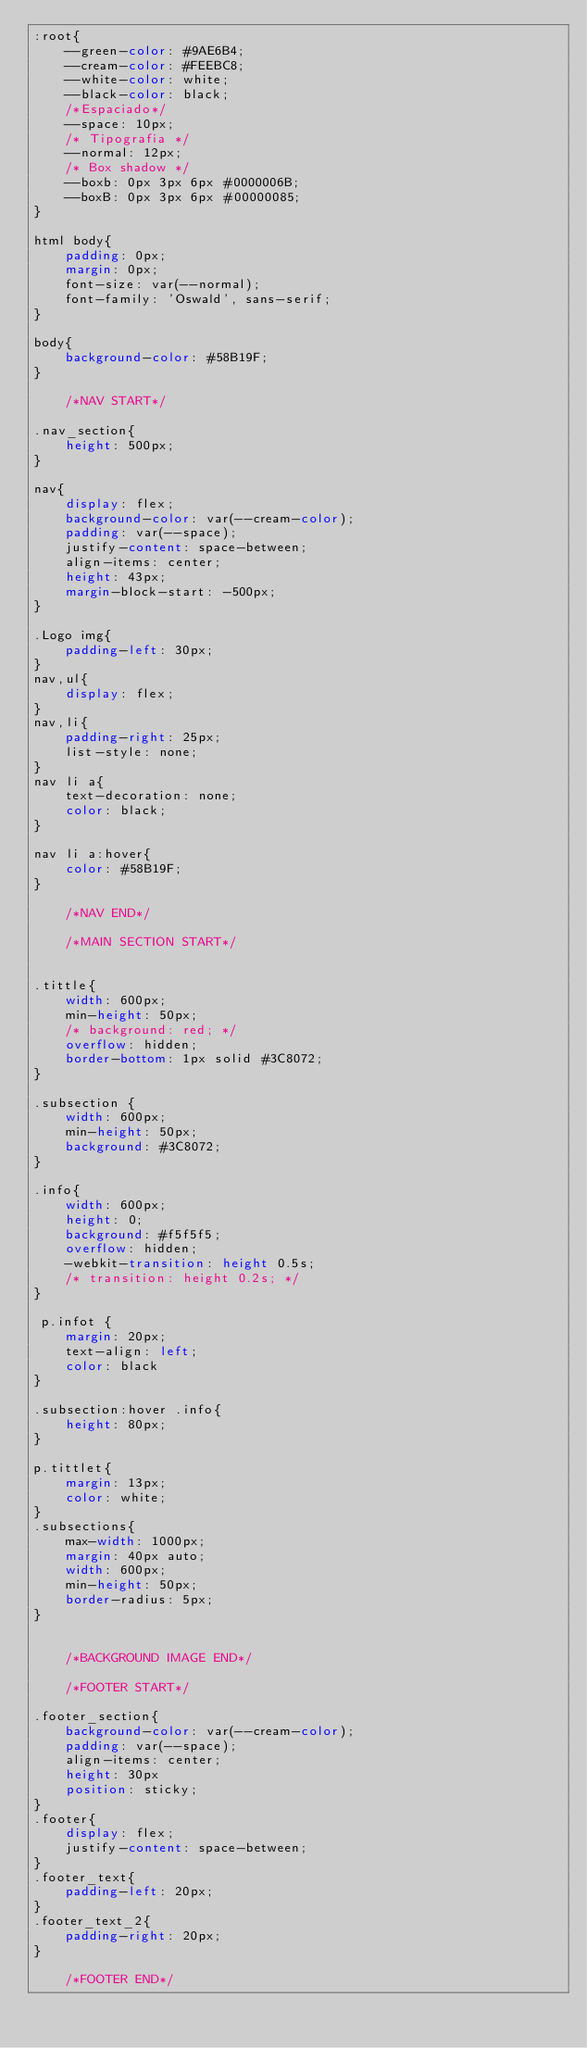<code> <loc_0><loc_0><loc_500><loc_500><_CSS_>:root{
	--green-color: #9AE6B4;
	--cream-color: #FEEBC8;
	--white-color: white;
	--black-color: black;
	/*Espaciado*/
	--space: 10px;
	/* Tipografia */
	--normal: 12px;
	/* Box shadow */
	--boxb: 0px 3px 6px #0000006B;
	--boxB: 0px 3px 6px #00000085;
}

html body{
	padding: 0px; 
	margin: 0px;
	font-size: var(--normal);
	font-family: 'Oswald', sans-serif;
}

body{
	background-color: #58B19F;
}

	/*NAV START*/

.nav_section{
	height: 500px;
}

nav{
	display: flex;
	background-color: var(--cream-color);
	padding: var(--space);
	justify-content: space-between;
	align-items: center;
	height: 43px;
	margin-block-start: -500px;
}

.Logo img{
	padding-left: 30px;
}
nav,ul{
	display: flex;
}
nav,li{
	padding-right: 25px; 
	list-style: none;
}
nav li a{
	text-decoration: none;
	color: black;
}

nav li a:hover{
	color: #58B19F;
}

	/*NAV END*/

	/*MAIN SECTION START*/


.tittle{
    width: 600px;
    min-height: 50px;
    /* background: red; */
    overflow: hidden;
    border-bottom: 1px solid #3C8072;
}

.subsection {
    width: 600px;
    min-height: 50px;
    background: #3C8072;
}

.info{
    width: 600px;
    height: 0;
    background: #f5f5f5;
    overflow: hidden;
    -webkit-transition: height 0.5s;
    /* transition: height 0.2s; */
}

 p.infot {
    margin: 20px;
    text-align: left;
    color: black
}

.subsection:hover .info{
    height: 80px;
}

p.tittlet{
    margin: 13px;
    color: white;
}
.subsections{
	max-width: 1000px;
	margin: 40px auto;
	width: 600px;
	min-height: 50px;
	border-radius: 5px;
}


	/*BACKGROUND IMAGE END*/

	/*FOOTER START*/

.footer_section{
	background-color: var(--cream-color);
	padding: var(--space);
	align-items: center;
	height: 30px
	position: sticky;
}
.footer{
	display: flex;
	justify-content: space-between;
}
.footer_text{
	padding-left: 20px;
}
.footer_text_2{
	padding-right: 20px;
}

	/*FOOTER END*/</code> 